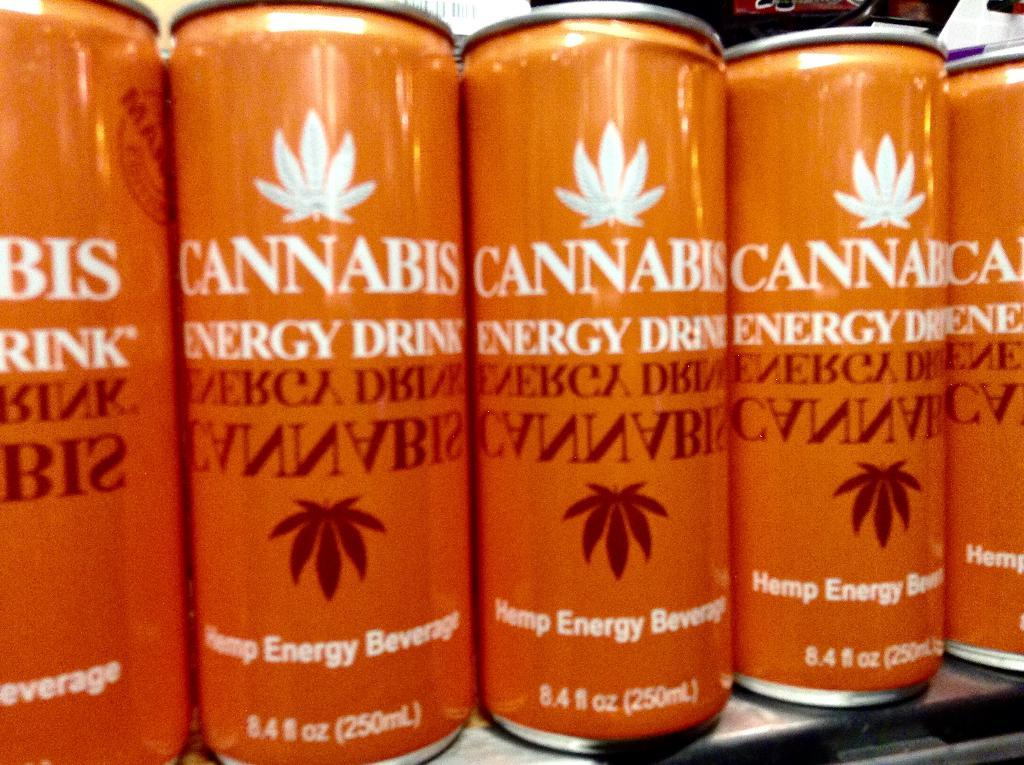<image>
Provide a brief description of the given image. The pictured can of hemp energy beverage is called Cannabis Energy Drink. 